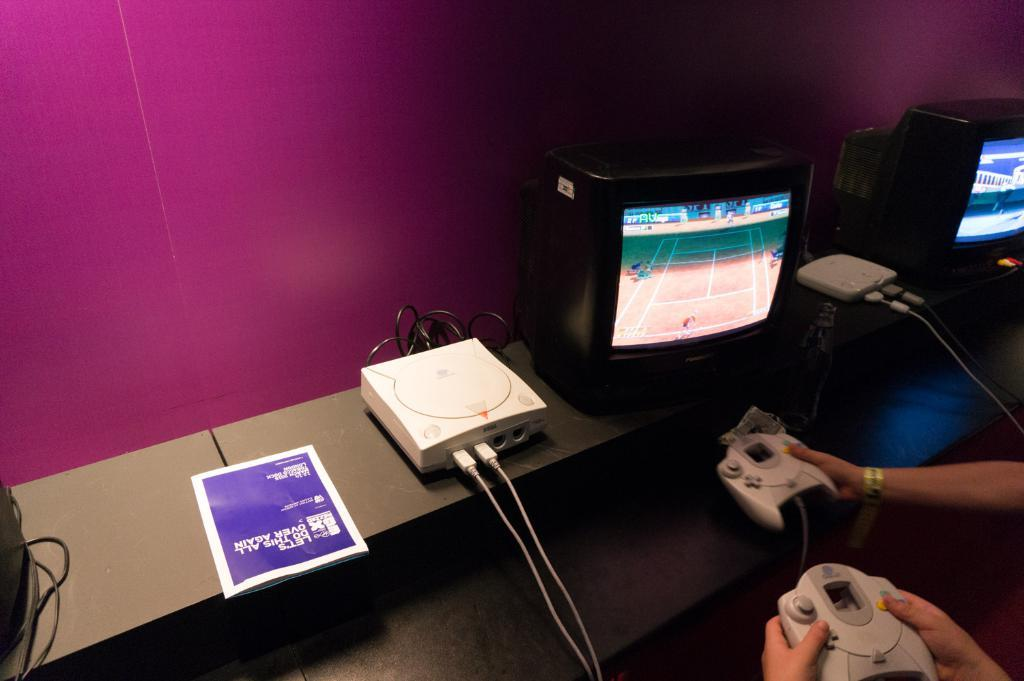<image>
Provide a brief description of the given image. A game of tennis is played on a screen next to a pamphlet which says lets do this all over again. 